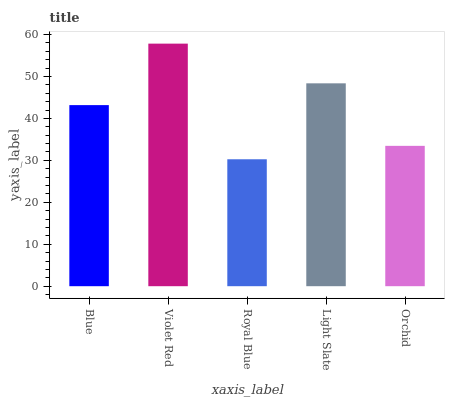Is Royal Blue the minimum?
Answer yes or no. Yes. Is Violet Red the maximum?
Answer yes or no. Yes. Is Violet Red the minimum?
Answer yes or no. No. Is Royal Blue the maximum?
Answer yes or no. No. Is Violet Red greater than Royal Blue?
Answer yes or no. Yes. Is Royal Blue less than Violet Red?
Answer yes or no. Yes. Is Royal Blue greater than Violet Red?
Answer yes or no. No. Is Violet Red less than Royal Blue?
Answer yes or no. No. Is Blue the high median?
Answer yes or no. Yes. Is Blue the low median?
Answer yes or no. Yes. Is Orchid the high median?
Answer yes or no. No. Is Orchid the low median?
Answer yes or no. No. 